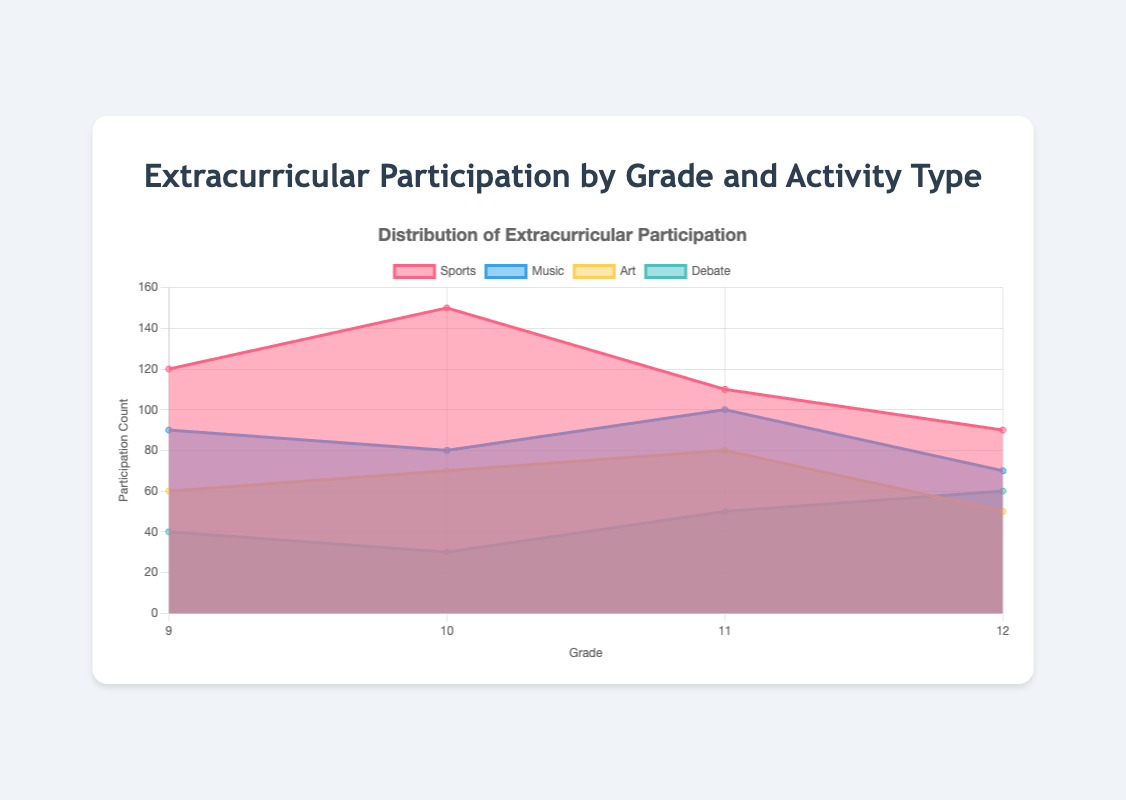What is the total participation count for Sports across all grades? To find the total participation count for Sports, sum the participation counts for Sports in each grade: 120 (Grade 9) + 150 (Grade 10) + 110 (Grade 11) + 90 (Grade 12). This gives 470.
Answer: 470 Which grade has the highest participation in Debate? Compare the participation counts for Debate across all grades: 40 (Grade 9), 30 (Grade 10), 50 (Grade 11), and 60 (Grade 12). Grade 12 has the highest participation in Debate with 60 participants.
Answer: Grade 12 Which activity type has a decreasing trend in participation from Grade 9 to Grade 12? Observe the participation counts for each activity type across grades. Sports has values 120 (Grade 9), 150 (Grade 10), 110 (Grade 11), and 90 (Grade 12), which indicates a fluctuating trend, but overall, it's decreasing.
Answer: Sports What is the difference in participation count in Music between Grade 9 and Grade 12? Subtract the participation count in Grade 12 from the participation count in Grade 9 for Music: 90 (Grade 9) - 70 (Grade 12) = 20.
Answer: 20 How many more students participate in Art in Grade 11 compared to Grade 9? Subtract the participation count in Grade 9 from the participation count in Grade 11 for Art: 80 (Grade 11) - 60 (Grade 9) = 20.
Answer: 20 What is the average participation count in Debate across all grades? Calculate the mean of participation counts in Debate: (40 + 30 + 50 + 60) / 4 = 45.
Answer: 45 Which activity type shows the most consistent participation count across all grades? Look for the smallest variance in participation counts: Debate has values 40, 30, 50, and 60, which fluctuate less compared to other activities.
Answer: Debate Which activity type saw an increase in participation from Grade 9 to Grade 10? Compare the participation counts between Grade 9 and Grade 10 for each activity type. Sports (120 to 150), Art (60 to 70), both show an increase.
Answer: Sports, Art 